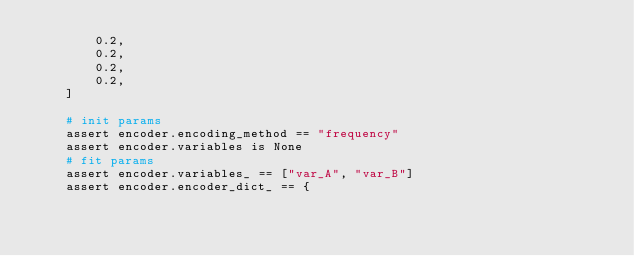<code> <loc_0><loc_0><loc_500><loc_500><_Python_>        0.2,
        0.2,
        0.2,
        0.2,
    ]

    # init params
    assert encoder.encoding_method == "frequency"
    assert encoder.variables is None
    # fit params
    assert encoder.variables_ == ["var_A", "var_B"]
    assert encoder.encoder_dict_ == {</code> 